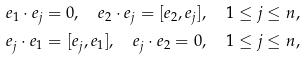<formula> <loc_0><loc_0><loc_500><loc_500>e _ { 1 } \cdot e _ { j } & = 0 , \quad e _ { 2 } \cdot e _ { j } = [ e _ { 2 } , e _ { j } ] , \quad 1 \leq j \leq n , \\ e _ { j } \cdot e _ { 1 } & = [ e _ { j } , e _ { 1 } ] , \quad e _ { j } \cdot e _ { 2 } = 0 , \quad 1 \leq j \leq n ,</formula> 